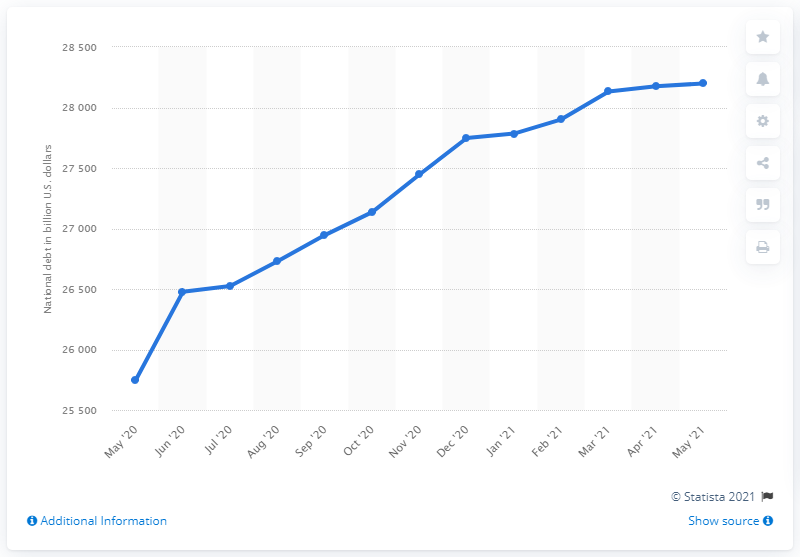Point out several critical features in this image. In May of 2021, the public debt of the United States was 257,462.60 dollars. The public debt of the United States in May 2021 was 28,199.01. 